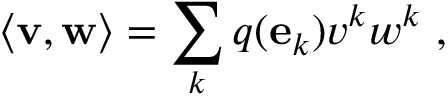Convert formula to latex. <formula><loc_0><loc_0><loc_500><loc_500>\langle v , w \rangle = \sum _ { k } q ( e _ { k } ) v ^ { k } w ^ { k } \ ,</formula> 